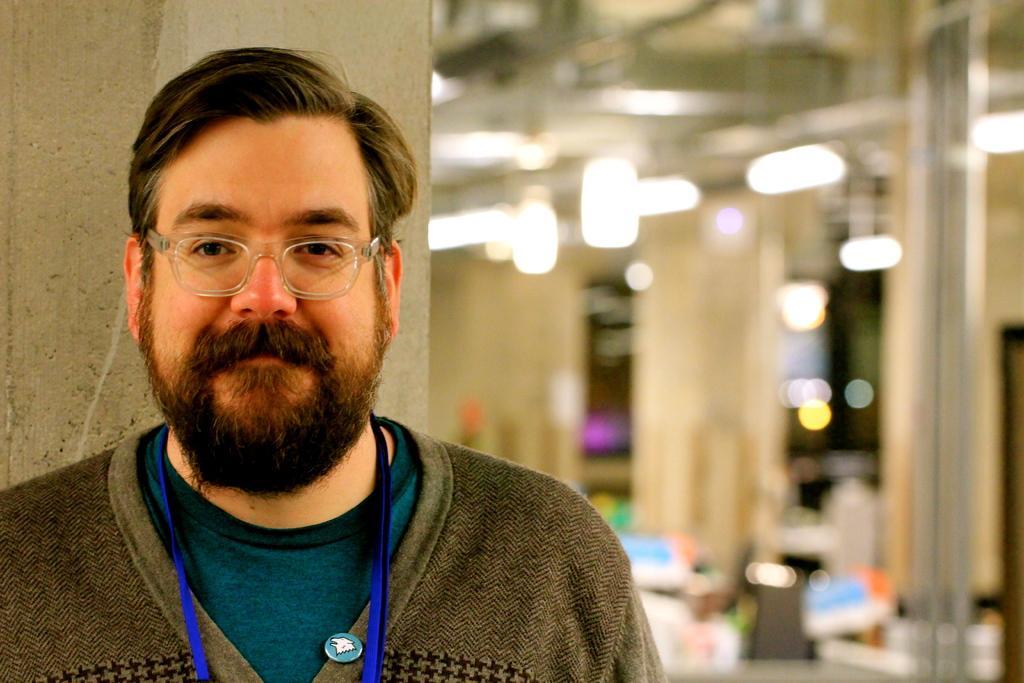Could you give a brief overview of what you see in this image? In the front of the image I can see a person wore spectacles. In the background of the image it is blurry and there are lights. 